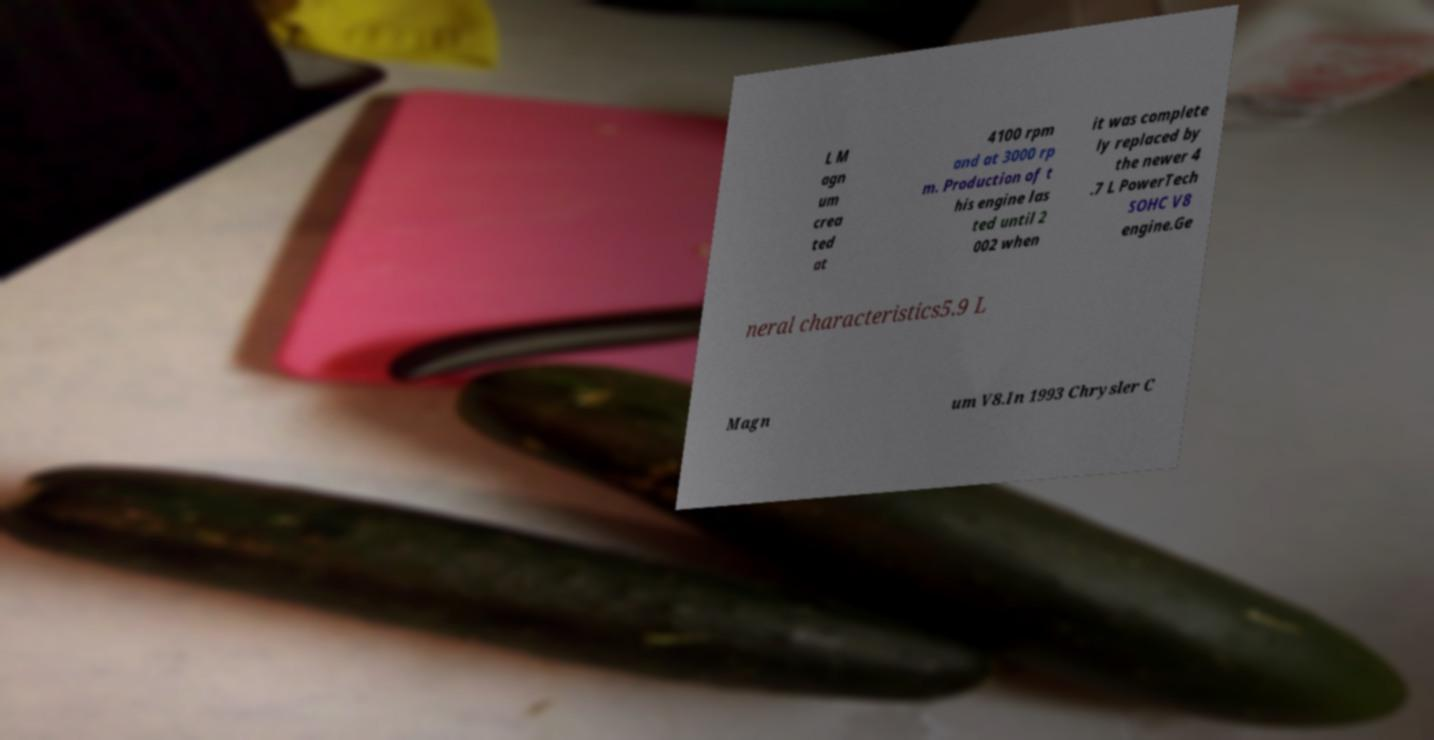What messages or text are displayed in this image? I need them in a readable, typed format. L M agn um crea ted at 4100 rpm and at 3000 rp m. Production of t his engine las ted until 2 002 when it was complete ly replaced by the newer 4 .7 L PowerTech SOHC V8 engine.Ge neral characteristics5.9 L Magn um V8.In 1993 Chrysler C 